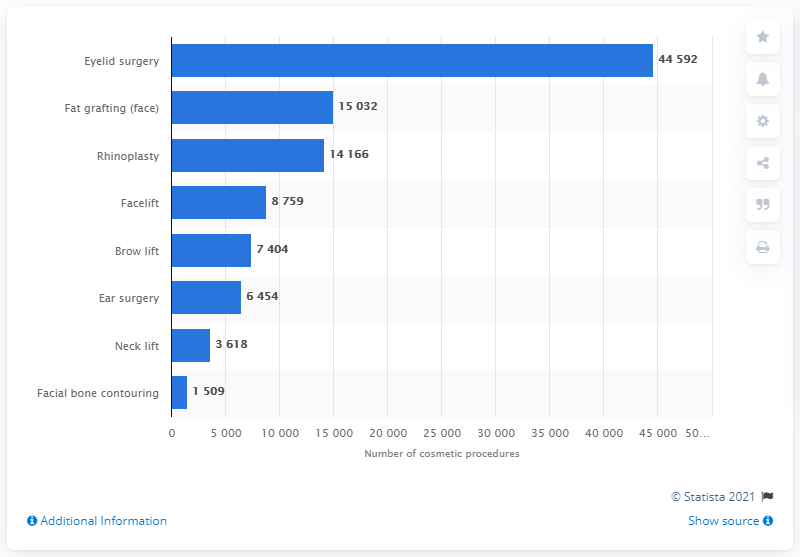List a handful of essential elements in this visual. In the year 2019, a total of 44,592 eyelid surgery procedures were performed in Germany. 